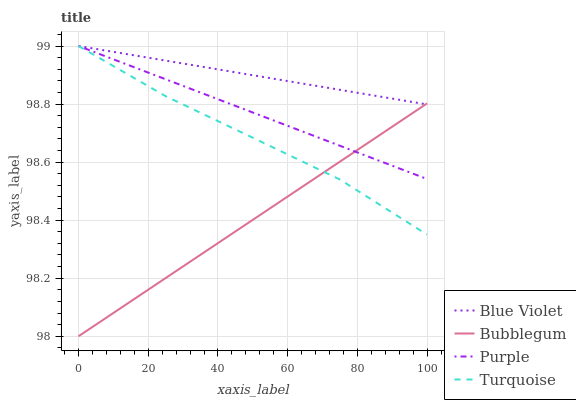Does Bubblegum have the minimum area under the curve?
Answer yes or no. Yes. Does Blue Violet have the maximum area under the curve?
Answer yes or no. Yes. Does Turquoise have the minimum area under the curve?
Answer yes or no. No. Does Turquoise have the maximum area under the curve?
Answer yes or no. No. Is Bubblegum the smoothest?
Answer yes or no. Yes. Is Turquoise the roughest?
Answer yes or no. Yes. Is Turquoise the smoothest?
Answer yes or no. No. Is Bubblegum the roughest?
Answer yes or no. No. Does Bubblegum have the lowest value?
Answer yes or no. Yes. Does Turquoise have the lowest value?
Answer yes or no. No. Does Blue Violet have the highest value?
Answer yes or no. Yes. Does Bubblegum have the highest value?
Answer yes or no. No. Does Purple intersect Blue Violet?
Answer yes or no. Yes. Is Purple less than Blue Violet?
Answer yes or no. No. Is Purple greater than Blue Violet?
Answer yes or no. No. 